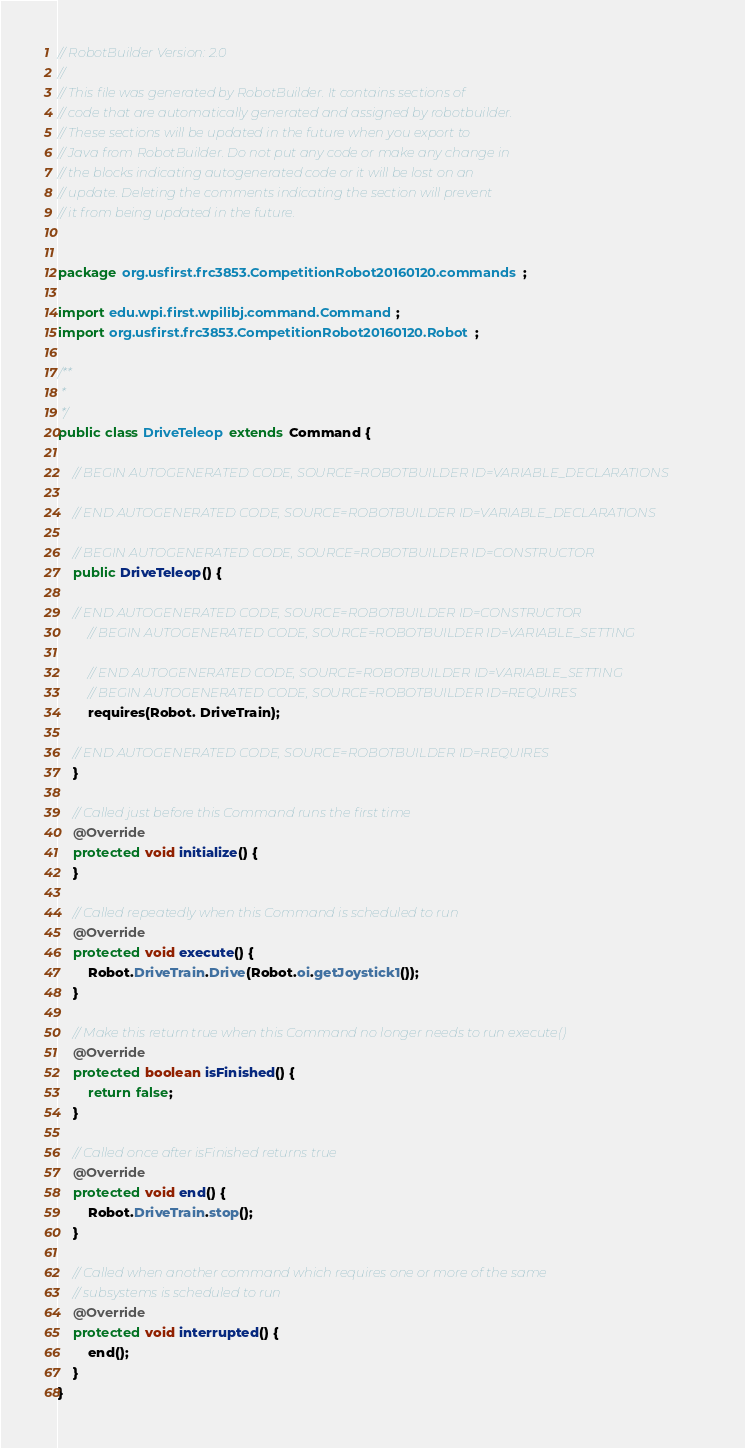<code> <loc_0><loc_0><loc_500><loc_500><_Java_>// RobotBuilder Version: 2.0
//
// This file was generated by RobotBuilder. It contains sections of
// code that are automatically generated and assigned by robotbuilder.
// These sections will be updated in the future when you export to
// Java from RobotBuilder. Do not put any code or make any change in
// the blocks indicating autogenerated code or it will be lost on an
// update. Deleting the comments indicating the section will prevent
// it from being updated in the future.


package org.usfirst.frc3853.CompetitionRobot20160120.commands;

import edu.wpi.first.wpilibj.command.Command;
import org.usfirst.frc3853.CompetitionRobot20160120.Robot;

/**
 *
 */
public class DriveTeleop extends Command {

    // BEGIN AUTOGENERATED CODE, SOURCE=ROBOTBUILDER ID=VARIABLE_DECLARATIONS
 
    // END AUTOGENERATED CODE, SOURCE=ROBOTBUILDER ID=VARIABLE_DECLARATIONS

    // BEGIN AUTOGENERATED CODE, SOURCE=ROBOTBUILDER ID=CONSTRUCTOR
    public DriveTeleop() {

    // END AUTOGENERATED CODE, SOURCE=ROBOTBUILDER ID=CONSTRUCTOR
        // BEGIN AUTOGENERATED CODE, SOURCE=ROBOTBUILDER ID=VARIABLE_SETTING

        // END AUTOGENERATED CODE, SOURCE=ROBOTBUILDER ID=VARIABLE_SETTING
        // BEGIN AUTOGENERATED CODE, SOURCE=ROBOTBUILDER ID=REQUIRES
        requires(Robot. DriveTrain);

    // END AUTOGENERATED CODE, SOURCE=ROBOTBUILDER ID=REQUIRES
    }

    // Called just before this Command runs the first time
    @Override
    protected void initialize() {
    }

    // Called repeatedly when this Command is scheduled to run
    @Override
    protected void execute() {
    	Robot.DriveTrain.Drive(Robot.oi.getJoystick1());
    }

    // Make this return true when this Command no longer needs to run execute()
    @Override
    protected boolean isFinished() {
        return false;
    }

    // Called once after isFinished returns true
    @Override
    protected void end() {
    	Robot.DriveTrain.stop();
    }

    // Called when another command which requires one or more of the same
    // subsystems is scheduled to run
    @Override
    protected void interrupted() {
    	end();
    }
}
</code> 